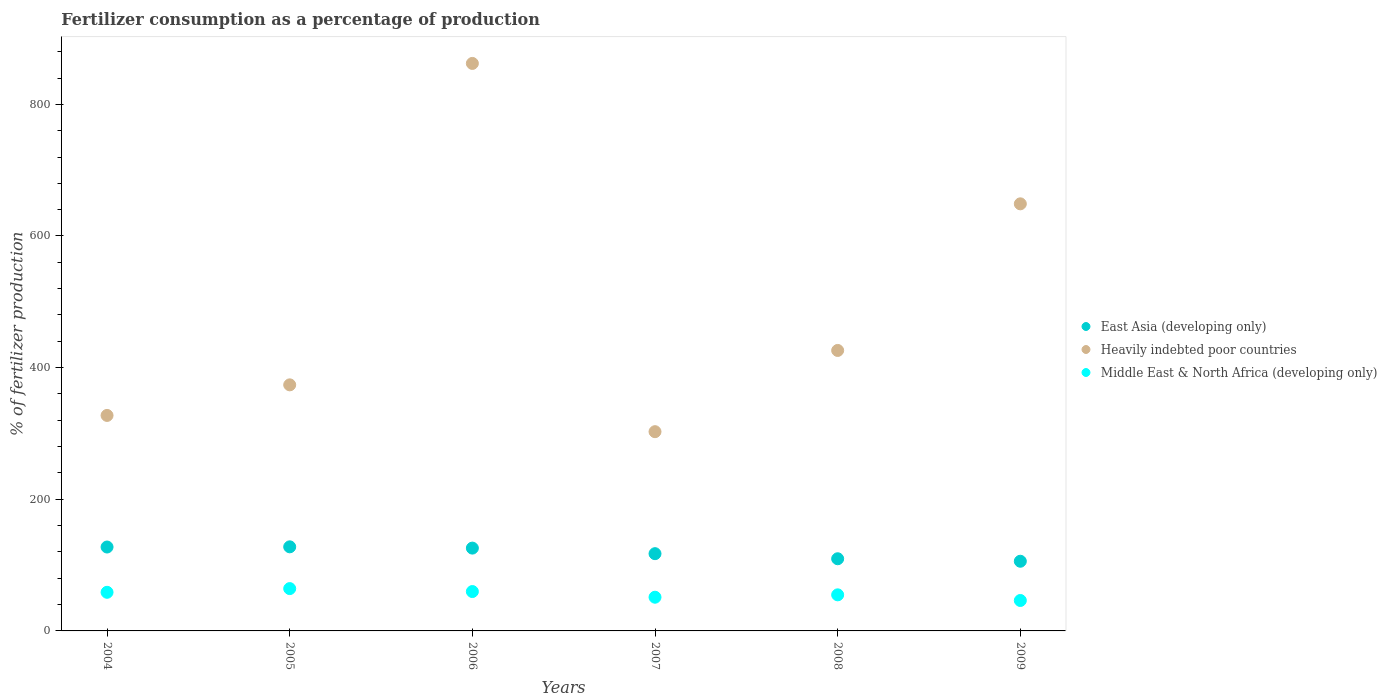What is the percentage of fertilizers consumed in East Asia (developing only) in 2006?
Your response must be concise. 125.81. Across all years, what is the maximum percentage of fertilizers consumed in East Asia (developing only)?
Keep it short and to the point. 127.76. Across all years, what is the minimum percentage of fertilizers consumed in East Asia (developing only)?
Keep it short and to the point. 105.86. In which year was the percentage of fertilizers consumed in Middle East & North Africa (developing only) minimum?
Provide a succinct answer. 2009. What is the total percentage of fertilizers consumed in Middle East & North Africa (developing only) in the graph?
Provide a short and direct response. 335.05. What is the difference between the percentage of fertilizers consumed in East Asia (developing only) in 2004 and that in 2009?
Provide a short and direct response. 21.61. What is the difference between the percentage of fertilizers consumed in Middle East & North Africa (developing only) in 2004 and the percentage of fertilizers consumed in Heavily indebted poor countries in 2008?
Make the answer very short. -367.43. What is the average percentage of fertilizers consumed in East Asia (developing only) per year?
Provide a succinct answer. 118.98. In the year 2005, what is the difference between the percentage of fertilizers consumed in East Asia (developing only) and percentage of fertilizers consumed in Heavily indebted poor countries?
Offer a terse response. -246.09. What is the ratio of the percentage of fertilizers consumed in Middle East & North Africa (developing only) in 2007 to that in 2009?
Ensure brevity in your answer.  1.11. Is the percentage of fertilizers consumed in Middle East & North Africa (developing only) in 2006 less than that in 2009?
Provide a succinct answer. No. Is the difference between the percentage of fertilizers consumed in East Asia (developing only) in 2008 and 2009 greater than the difference between the percentage of fertilizers consumed in Heavily indebted poor countries in 2008 and 2009?
Provide a short and direct response. Yes. What is the difference between the highest and the second highest percentage of fertilizers consumed in Heavily indebted poor countries?
Give a very brief answer. 213.31. What is the difference between the highest and the lowest percentage of fertilizers consumed in Middle East & North Africa (developing only)?
Provide a succinct answer. 18.06. Is the sum of the percentage of fertilizers consumed in East Asia (developing only) in 2007 and 2008 greater than the maximum percentage of fertilizers consumed in Heavily indebted poor countries across all years?
Make the answer very short. No. Does the percentage of fertilizers consumed in Middle East & North Africa (developing only) monotonically increase over the years?
Keep it short and to the point. No. Is the percentage of fertilizers consumed in Heavily indebted poor countries strictly greater than the percentage of fertilizers consumed in Middle East & North Africa (developing only) over the years?
Give a very brief answer. Yes. Is the percentage of fertilizers consumed in East Asia (developing only) strictly less than the percentage of fertilizers consumed in Heavily indebted poor countries over the years?
Your response must be concise. Yes. How many dotlines are there?
Offer a very short reply. 3. Where does the legend appear in the graph?
Give a very brief answer. Center right. How many legend labels are there?
Your answer should be very brief. 3. How are the legend labels stacked?
Make the answer very short. Vertical. What is the title of the graph?
Offer a terse response. Fertilizer consumption as a percentage of production. What is the label or title of the Y-axis?
Your answer should be very brief. % of fertilizer production. What is the % of fertilizer production in East Asia (developing only) in 2004?
Ensure brevity in your answer.  127.47. What is the % of fertilizer production of Heavily indebted poor countries in 2004?
Your answer should be very brief. 327.38. What is the % of fertilizer production in Middle East & North Africa (developing only) in 2004?
Offer a very short reply. 58.68. What is the % of fertilizer production in East Asia (developing only) in 2005?
Make the answer very short. 127.76. What is the % of fertilizer production of Heavily indebted poor countries in 2005?
Offer a terse response. 373.84. What is the % of fertilizer production in Middle East & North Africa (developing only) in 2005?
Give a very brief answer. 64.3. What is the % of fertilizer production in East Asia (developing only) in 2006?
Your response must be concise. 125.81. What is the % of fertilizer production in Heavily indebted poor countries in 2006?
Keep it short and to the point. 862.17. What is the % of fertilizer production in Middle East & North Africa (developing only) in 2006?
Provide a short and direct response. 59.82. What is the % of fertilizer production in East Asia (developing only) in 2007?
Offer a terse response. 117.36. What is the % of fertilizer production of Heavily indebted poor countries in 2007?
Make the answer very short. 302.7. What is the % of fertilizer production of Middle East & North Africa (developing only) in 2007?
Provide a short and direct response. 51.2. What is the % of fertilizer production in East Asia (developing only) in 2008?
Your answer should be compact. 109.65. What is the % of fertilizer production in Heavily indebted poor countries in 2008?
Give a very brief answer. 426.11. What is the % of fertilizer production in Middle East & North Africa (developing only) in 2008?
Offer a terse response. 54.82. What is the % of fertilizer production in East Asia (developing only) in 2009?
Offer a terse response. 105.86. What is the % of fertilizer production in Heavily indebted poor countries in 2009?
Keep it short and to the point. 648.85. What is the % of fertilizer production in Middle East & North Africa (developing only) in 2009?
Provide a succinct answer. 46.24. Across all years, what is the maximum % of fertilizer production in East Asia (developing only)?
Provide a short and direct response. 127.76. Across all years, what is the maximum % of fertilizer production in Heavily indebted poor countries?
Give a very brief answer. 862.17. Across all years, what is the maximum % of fertilizer production of Middle East & North Africa (developing only)?
Give a very brief answer. 64.3. Across all years, what is the minimum % of fertilizer production in East Asia (developing only)?
Offer a terse response. 105.86. Across all years, what is the minimum % of fertilizer production in Heavily indebted poor countries?
Keep it short and to the point. 302.7. Across all years, what is the minimum % of fertilizer production in Middle East & North Africa (developing only)?
Offer a very short reply. 46.24. What is the total % of fertilizer production in East Asia (developing only) in the graph?
Your response must be concise. 713.9. What is the total % of fertilizer production of Heavily indebted poor countries in the graph?
Offer a terse response. 2941.05. What is the total % of fertilizer production in Middle East & North Africa (developing only) in the graph?
Provide a succinct answer. 335.05. What is the difference between the % of fertilizer production of East Asia (developing only) in 2004 and that in 2005?
Your response must be concise. -0.29. What is the difference between the % of fertilizer production of Heavily indebted poor countries in 2004 and that in 2005?
Make the answer very short. -46.46. What is the difference between the % of fertilizer production of Middle East & North Africa (developing only) in 2004 and that in 2005?
Make the answer very short. -5.62. What is the difference between the % of fertilizer production in East Asia (developing only) in 2004 and that in 2006?
Keep it short and to the point. 1.65. What is the difference between the % of fertilizer production in Heavily indebted poor countries in 2004 and that in 2006?
Your answer should be very brief. -534.78. What is the difference between the % of fertilizer production in Middle East & North Africa (developing only) in 2004 and that in 2006?
Offer a terse response. -1.15. What is the difference between the % of fertilizer production in East Asia (developing only) in 2004 and that in 2007?
Offer a very short reply. 10.11. What is the difference between the % of fertilizer production of Heavily indebted poor countries in 2004 and that in 2007?
Provide a short and direct response. 24.69. What is the difference between the % of fertilizer production of Middle East & North Africa (developing only) in 2004 and that in 2007?
Your response must be concise. 7.47. What is the difference between the % of fertilizer production in East Asia (developing only) in 2004 and that in 2008?
Your answer should be compact. 17.82. What is the difference between the % of fertilizer production of Heavily indebted poor countries in 2004 and that in 2008?
Your answer should be compact. -98.72. What is the difference between the % of fertilizer production in Middle East & North Africa (developing only) in 2004 and that in 2008?
Your answer should be compact. 3.86. What is the difference between the % of fertilizer production in East Asia (developing only) in 2004 and that in 2009?
Provide a succinct answer. 21.61. What is the difference between the % of fertilizer production of Heavily indebted poor countries in 2004 and that in 2009?
Provide a short and direct response. -321.47. What is the difference between the % of fertilizer production of Middle East & North Africa (developing only) in 2004 and that in 2009?
Your response must be concise. 12.44. What is the difference between the % of fertilizer production of East Asia (developing only) in 2005 and that in 2006?
Give a very brief answer. 1.94. What is the difference between the % of fertilizer production in Heavily indebted poor countries in 2005 and that in 2006?
Make the answer very short. -488.32. What is the difference between the % of fertilizer production in Middle East & North Africa (developing only) in 2005 and that in 2006?
Your answer should be compact. 4.48. What is the difference between the % of fertilizer production of East Asia (developing only) in 2005 and that in 2007?
Your response must be concise. 10.39. What is the difference between the % of fertilizer production in Heavily indebted poor countries in 2005 and that in 2007?
Your response must be concise. 71.14. What is the difference between the % of fertilizer production in Middle East & North Africa (developing only) in 2005 and that in 2007?
Make the answer very short. 13.1. What is the difference between the % of fertilizer production of East Asia (developing only) in 2005 and that in 2008?
Give a very brief answer. 18.11. What is the difference between the % of fertilizer production in Heavily indebted poor countries in 2005 and that in 2008?
Make the answer very short. -52.27. What is the difference between the % of fertilizer production of Middle East & North Africa (developing only) in 2005 and that in 2008?
Provide a short and direct response. 9.48. What is the difference between the % of fertilizer production of East Asia (developing only) in 2005 and that in 2009?
Offer a terse response. 21.9. What is the difference between the % of fertilizer production in Heavily indebted poor countries in 2005 and that in 2009?
Ensure brevity in your answer.  -275.01. What is the difference between the % of fertilizer production of Middle East & North Africa (developing only) in 2005 and that in 2009?
Make the answer very short. 18.06. What is the difference between the % of fertilizer production in East Asia (developing only) in 2006 and that in 2007?
Offer a very short reply. 8.45. What is the difference between the % of fertilizer production of Heavily indebted poor countries in 2006 and that in 2007?
Offer a very short reply. 559.47. What is the difference between the % of fertilizer production in Middle East & North Africa (developing only) in 2006 and that in 2007?
Provide a short and direct response. 8.62. What is the difference between the % of fertilizer production in East Asia (developing only) in 2006 and that in 2008?
Provide a short and direct response. 16.17. What is the difference between the % of fertilizer production in Heavily indebted poor countries in 2006 and that in 2008?
Give a very brief answer. 436.06. What is the difference between the % of fertilizer production in Middle East & North Africa (developing only) in 2006 and that in 2008?
Ensure brevity in your answer.  5. What is the difference between the % of fertilizer production of East Asia (developing only) in 2006 and that in 2009?
Provide a short and direct response. 19.96. What is the difference between the % of fertilizer production in Heavily indebted poor countries in 2006 and that in 2009?
Offer a terse response. 213.31. What is the difference between the % of fertilizer production in Middle East & North Africa (developing only) in 2006 and that in 2009?
Provide a short and direct response. 13.58. What is the difference between the % of fertilizer production in East Asia (developing only) in 2007 and that in 2008?
Your response must be concise. 7.72. What is the difference between the % of fertilizer production in Heavily indebted poor countries in 2007 and that in 2008?
Your answer should be very brief. -123.41. What is the difference between the % of fertilizer production of Middle East & North Africa (developing only) in 2007 and that in 2008?
Offer a terse response. -3.61. What is the difference between the % of fertilizer production of East Asia (developing only) in 2007 and that in 2009?
Your answer should be very brief. 11.51. What is the difference between the % of fertilizer production in Heavily indebted poor countries in 2007 and that in 2009?
Offer a very short reply. -346.16. What is the difference between the % of fertilizer production of Middle East & North Africa (developing only) in 2007 and that in 2009?
Provide a succinct answer. 4.96. What is the difference between the % of fertilizer production of East Asia (developing only) in 2008 and that in 2009?
Your response must be concise. 3.79. What is the difference between the % of fertilizer production of Heavily indebted poor countries in 2008 and that in 2009?
Ensure brevity in your answer.  -222.75. What is the difference between the % of fertilizer production in Middle East & North Africa (developing only) in 2008 and that in 2009?
Provide a succinct answer. 8.58. What is the difference between the % of fertilizer production in East Asia (developing only) in 2004 and the % of fertilizer production in Heavily indebted poor countries in 2005?
Provide a succinct answer. -246.37. What is the difference between the % of fertilizer production of East Asia (developing only) in 2004 and the % of fertilizer production of Middle East & North Africa (developing only) in 2005?
Offer a very short reply. 63.17. What is the difference between the % of fertilizer production in Heavily indebted poor countries in 2004 and the % of fertilizer production in Middle East & North Africa (developing only) in 2005?
Provide a short and direct response. 263.09. What is the difference between the % of fertilizer production in East Asia (developing only) in 2004 and the % of fertilizer production in Heavily indebted poor countries in 2006?
Offer a very short reply. -734.7. What is the difference between the % of fertilizer production of East Asia (developing only) in 2004 and the % of fertilizer production of Middle East & North Africa (developing only) in 2006?
Give a very brief answer. 67.65. What is the difference between the % of fertilizer production in Heavily indebted poor countries in 2004 and the % of fertilizer production in Middle East & North Africa (developing only) in 2006?
Provide a succinct answer. 267.56. What is the difference between the % of fertilizer production in East Asia (developing only) in 2004 and the % of fertilizer production in Heavily indebted poor countries in 2007?
Offer a very short reply. -175.23. What is the difference between the % of fertilizer production of East Asia (developing only) in 2004 and the % of fertilizer production of Middle East & North Africa (developing only) in 2007?
Provide a succinct answer. 76.27. What is the difference between the % of fertilizer production in Heavily indebted poor countries in 2004 and the % of fertilizer production in Middle East & North Africa (developing only) in 2007?
Your answer should be very brief. 276.18. What is the difference between the % of fertilizer production of East Asia (developing only) in 2004 and the % of fertilizer production of Heavily indebted poor countries in 2008?
Your response must be concise. -298.64. What is the difference between the % of fertilizer production of East Asia (developing only) in 2004 and the % of fertilizer production of Middle East & North Africa (developing only) in 2008?
Keep it short and to the point. 72.65. What is the difference between the % of fertilizer production in Heavily indebted poor countries in 2004 and the % of fertilizer production in Middle East & North Africa (developing only) in 2008?
Your response must be concise. 272.57. What is the difference between the % of fertilizer production of East Asia (developing only) in 2004 and the % of fertilizer production of Heavily indebted poor countries in 2009?
Give a very brief answer. -521.39. What is the difference between the % of fertilizer production of East Asia (developing only) in 2004 and the % of fertilizer production of Middle East & North Africa (developing only) in 2009?
Your answer should be very brief. 81.23. What is the difference between the % of fertilizer production in Heavily indebted poor countries in 2004 and the % of fertilizer production in Middle East & North Africa (developing only) in 2009?
Ensure brevity in your answer.  281.14. What is the difference between the % of fertilizer production in East Asia (developing only) in 2005 and the % of fertilizer production in Heavily indebted poor countries in 2006?
Ensure brevity in your answer.  -734.41. What is the difference between the % of fertilizer production in East Asia (developing only) in 2005 and the % of fertilizer production in Middle East & North Africa (developing only) in 2006?
Offer a very short reply. 67.94. What is the difference between the % of fertilizer production of Heavily indebted poor countries in 2005 and the % of fertilizer production of Middle East & North Africa (developing only) in 2006?
Offer a terse response. 314.02. What is the difference between the % of fertilizer production in East Asia (developing only) in 2005 and the % of fertilizer production in Heavily indebted poor countries in 2007?
Your answer should be very brief. -174.94. What is the difference between the % of fertilizer production in East Asia (developing only) in 2005 and the % of fertilizer production in Middle East & North Africa (developing only) in 2007?
Make the answer very short. 76.56. What is the difference between the % of fertilizer production of Heavily indebted poor countries in 2005 and the % of fertilizer production of Middle East & North Africa (developing only) in 2007?
Keep it short and to the point. 322.64. What is the difference between the % of fertilizer production in East Asia (developing only) in 2005 and the % of fertilizer production in Heavily indebted poor countries in 2008?
Make the answer very short. -298.35. What is the difference between the % of fertilizer production of East Asia (developing only) in 2005 and the % of fertilizer production of Middle East & North Africa (developing only) in 2008?
Provide a short and direct response. 72.94. What is the difference between the % of fertilizer production in Heavily indebted poor countries in 2005 and the % of fertilizer production in Middle East & North Africa (developing only) in 2008?
Make the answer very short. 319.03. What is the difference between the % of fertilizer production in East Asia (developing only) in 2005 and the % of fertilizer production in Heavily indebted poor countries in 2009?
Keep it short and to the point. -521.1. What is the difference between the % of fertilizer production in East Asia (developing only) in 2005 and the % of fertilizer production in Middle East & North Africa (developing only) in 2009?
Your answer should be very brief. 81.52. What is the difference between the % of fertilizer production in Heavily indebted poor countries in 2005 and the % of fertilizer production in Middle East & North Africa (developing only) in 2009?
Your answer should be compact. 327.6. What is the difference between the % of fertilizer production of East Asia (developing only) in 2006 and the % of fertilizer production of Heavily indebted poor countries in 2007?
Offer a terse response. -176.88. What is the difference between the % of fertilizer production of East Asia (developing only) in 2006 and the % of fertilizer production of Middle East & North Africa (developing only) in 2007?
Ensure brevity in your answer.  74.61. What is the difference between the % of fertilizer production in Heavily indebted poor countries in 2006 and the % of fertilizer production in Middle East & North Africa (developing only) in 2007?
Provide a succinct answer. 810.96. What is the difference between the % of fertilizer production in East Asia (developing only) in 2006 and the % of fertilizer production in Heavily indebted poor countries in 2008?
Your response must be concise. -300.29. What is the difference between the % of fertilizer production in East Asia (developing only) in 2006 and the % of fertilizer production in Middle East & North Africa (developing only) in 2008?
Offer a very short reply. 71. What is the difference between the % of fertilizer production in Heavily indebted poor countries in 2006 and the % of fertilizer production in Middle East & North Africa (developing only) in 2008?
Keep it short and to the point. 807.35. What is the difference between the % of fertilizer production in East Asia (developing only) in 2006 and the % of fertilizer production in Heavily indebted poor countries in 2009?
Provide a succinct answer. -523.04. What is the difference between the % of fertilizer production of East Asia (developing only) in 2006 and the % of fertilizer production of Middle East & North Africa (developing only) in 2009?
Your answer should be compact. 79.58. What is the difference between the % of fertilizer production of Heavily indebted poor countries in 2006 and the % of fertilizer production of Middle East & North Africa (developing only) in 2009?
Your answer should be very brief. 815.93. What is the difference between the % of fertilizer production of East Asia (developing only) in 2007 and the % of fertilizer production of Heavily indebted poor countries in 2008?
Your answer should be very brief. -308.75. What is the difference between the % of fertilizer production of East Asia (developing only) in 2007 and the % of fertilizer production of Middle East & North Africa (developing only) in 2008?
Keep it short and to the point. 62.55. What is the difference between the % of fertilizer production of Heavily indebted poor countries in 2007 and the % of fertilizer production of Middle East & North Africa (developing only) in 2008?
Make the answer very short. 247.88. What is the difference between the % of fertilizer production in East Asia (developing only) in 2007 and the % of fertilizer production in Heavily indebted poor countries in 2009?
Ensure brevity in your answer.  -531.49. What is the difference between the % of fertilizer production of East Asia (developing only) in 2007 and the % of fertilizer production of Middle East & North Africa (developing only) in 2009?
Provide a short and direct response. 71.12. What is the difference between the % of fertilizer production of Heavily indebted poor countries in 2007 and the % of fertilizer production of Middle East & North Africa (developing only) in 2009?
Your answer should be very brief. 256.46. What is the difference between the % of fertilizer production in East Asia (developing only) in 2008 and the % of fertilizer production in Heavily indebted poor countries in 2009?
Offer a very short reply. -539.21. What is the difference between the % of fertilizer production in East Asia (developing only) in 2008 and the % of fertilizer production in Middle East & North Africa (developing only) in 2009?
Offer a terse response. 63.41. What is the difference between the % of fertilizer production in Heavily indebted poor countries in 2008 and the % of fertilizer production in Middle East & North Africa (developing only) in 2009?
Provide a short and direct response. 379.87. What is the average % of fertilizer production of East Asia (developing only) per year?
Your answer should be very brief. 118.98. What is the average % of fertilizer production of Heavily indebted poor countries per year?
Your answer should be compact. 490.18. What is the average % of fertilizer production of Middle East & North Africa (developing only) per year?
Make the answer very short. 55.84. In the year 2004, what is the difference between the % of fertilizer production in East Asia (developing only) and % of fertilizer production in Heavily indebted poor countries?
Provide a short and direct response. -199.92. In the year 2004, what is the difference between the % of fertilizer production in East Asia (developing only) and % of fertilizer production in Middle East & North Africa (developing only)?
Provide a short and direct response. 68.79. In the year 2004, what is the difference between the % of fertilizer production of Heavily indebted poor countries and % of fertilizer production of Middle East & North Africa (developing only)?
Provide a succinct answer. 268.71. In the year 2005, what is the difference between the % of fertilizer production in East Asia (developing only) and % of fertilizer production in Heavily indebted poor countries?
Keep it short and to the point. -246.09. In the year 2005, what is the difference between the % of fertilizer production in East Asia (developing only) and % of fertilizer production in Middle East & North Africa (developing only)?
Your answer should be very brief. 63.46. In the year 2005, what is the difference between the % of fertilizer production in Heavily indebted poor countries and % of fertilizer production in Middle East & North Africa (developing only)?
Your answer should be very brief. 309.54. In the year 2006, what is the difference between the % of fertilizer production in East Asia (developing only) and % of fertilizer production in Heavily indebted poor countries?
Offer a terse response. -736.35. In the year 2006, what is the difference between the % of fertilizer production in East Asia (developing only) and % of fertilizer production in Middle East & North Africa (developing only)?
Provide a short and direct response. 65.99. In the year 2006, what is the difference between the % of fertilizer production in Heavily indebted poor countries and % of fertilizer production in Middle East & North Africa (developing only)?
Keep it short and to the point. 802.35. In the year 2007, what is the difference between the % of fertilizer production of East Asia (developing only) and % of fertilizer production of Heavily indebted poor countries?
Provide a short and direct response. -185.33. In the year 2007, what is the difference between the % of fertilizer production of East Asia (developing only) and % of fertilizer production of Middle East & North Africa (developing only)?
Keep it short and to the point. 66.16. In the year 2007, what is the difference between the % of fertilizer production of Heavily indebted poor countries and % of fertilizer production of Middle East & North Africa (developing only)?
Provide a short and direct response. 251.5. In the year 2008, what is the difference between the % of fertilizer production in East Asia (developing only) and % of fertilizer production in Heavily indebted poor countries?
Give a very brief answer. -316.46. In the year 2008, what is the difference between the % of fertilizer production in East Asia (developing only) and % of fertilizer production in Middle East & North Africa (developing only)?
Your answer should be compact. 54.83. In the year 2008, what is the difference between the % of fertilizer production in Heavily indebted poor countries and % of fertilizer production in Middle East & North Africa (developing only)?
Offer a terse response. 371.29. In the year 2009, what is the difference between the % of fertilizer production of East Asia (developing only) and % of fertilizer production of Heavily indebted poor countries?
Give a very brief answer. -543. In the year 2009, what is the difference between the % of fertilizer production in East Asia (developing only) and % of fertilizer production in Middle East & North Africa (developing only)?
Offer a very short reply. 59.62. In the year 2009, what is the difference between the % of fertilizer production of Heavily indebted poor countries and % of fertilizer production of Middle East & North Africa (developing only)?
Give a very brief answer. 602.61. What is the ratio of the % of fertilizer production of East Asia (developing only) in 2004 to that in 2005?
Ensure brevity in your answer.  1. What is the ratio of the % of fertilizer production in Heavily indebted poor countries in 2004 to that in 2005?
Make the answer very short. 0.88. What is the ratio of the % of fertilizer production in Middle East & North Africa (developing only) in 2004 to that in 2005?
Provide a succinct answer. 0.91. What is the ratio of the % of fertilizer production of East Asia (developing only) in 2004 to that in 2006?
Provide a short and direct response. 1.01. What is the ratio of the % of fertilizer production in Heavily indebted poor countries in 2004 to that in 2006?
Provide a succinct answer. 0.38. What is the ratio of the % of fertilizer production of Middle East & North Africa (developing only) in 2004 to that in 2006?
Ensure brevity in your answer.  0.98. What is the ratio of the % of fertilizer production in East Asia (developing only) in 2004 to that in 2007?
Provide a short and direct response. 1.09. What is the ratio of the % of fertilizer production in Heavily indebted poor countries in 2004 to that in 2007?
Offer a terse response. 1.08. What is the ratio of the % of fertilizer production of Middle East & North Africa (developing only) in 2004 to that in 2007?
Your response must be concise. 1.15. What is the ratio of the % of fertilizer production in East Asia (developing only) in 2004 to that in 2008?
Your response must be concise. 1.16. What is the ratio of the % of fertilizer production in Heavily indebted poor countries in 2004 to that in 2008?
Offer a very short reply. 0.77. What is the ratio of the % of fertilizer production of Middle East & North Africa (developing only) in 2004 to that in 2008?
Give a very brief answer. 1.07. What is the ratio of the % of fertilizer production in East Asia (developing only) in 2004 to that in 2009?
Your answer should be very brief. 1.2. What is the ratio of the % of fertilizer production of Heavily indebted poor countries in 2004 to that in 2009?
Your response must be concise. 0.5. What is the ratio of the % of fertilizer production in Middle East & North Africa (developing only) in 2004 to that in 2009?
Provide a short and direct response. 1.27. What is the ratio of the % of fertilizer production in East Asia (developing only) in 2005 to that in 2006?
Your response must be concise. 1.02. What is the ratio of the % of fertilizer production of Heavily indebted poor countries in 2005 to that in 2006?
Offer a terse response. 0.43. What is the ratio of the % of fertilizer production of Middle East & North Africa (developing only) in 2005 to that in 2006?
Make the answer very short. 1.07. What is the ratio of the % of fertilizer production in East Asia (developing only) in 2005 to that in 2007?
Your response must be concise. 1.09. What is the ratio of the % of fertilizer production in Heavily indebted poor countries in 2005 to that in 2007?
Provide a succinct answer. 1.24. What is the ratio of the % of fertilizer production of Middle East & North Africa (developing only) in 2005 to that in 2007?
Your response must be concise. 1.26. What is the ratio of the % of fertilizer production in East Asia (developing only) in 2005 to that in 2008?
Offer a terse response. 1.17. What is the ratio of the % of fertilizer production in Heavily indebted poor countries in 2005 to that in 2008?
Offer a very short reply. 0.88. What is the ratio of the % of fertilizer production in Middle East & North Africa (developing only) in 2005 to that in 2008?
Give a very brief answer. 1.17. What is the ratio of the % of fertilizer production in East Asia (developing only) in 2005 to that in 2009?
Make the answer very short. 1.21. What is the ratio of the % of fertilizer production of Heavily indebted poor countries in 2005 to that in 2009?
Your answer should be very brief. 0.58. What is the ratio of the % of fertilizer production of Middle East & North Africa (developing only) in 2005 to that in 2009?
Ensure brevity in your answer.  1.39. What is the ratio of the % of fertilizer production of East Asia (developing only) in 2006 to that in 2007?
Offer a terse response. 1.07. What is the ratio of the % of fertilizer production of Heavily indebted poor countries in 2006 to that in 2007?
Your answer should be very brief. 2.85. What is the ratio of the % of fertilizer production of Middle East & North Africa (developing only) in 2006 to that in 2007?
Give a very brief answer. 1.17. What is the ratio of the % of fertilizer production of East Asia (developing only) in 2006 to that in 2008?
Keep it short and to the point. 1.15. What is the ratio of the % of fertilizer production in Heavily indebted poor countries in 2006 to that in 2008?
Your response must be concise. 2.02. What is the ratio of the % of fertilizer production of Middle East & North Africa (developing only) in 2006 to that in 2008?
Offer a very short reply. 1.09. What is the ratio of the % of fertilizer production of East Asia (developing only) in 2006 to that in 2009?
Keep it short and to the point. 1.19. What is the ratio of the % of fertilizer production of Heavily indebted poor countries in 2006 to that in 2009?
Give a very brief answer. 1.33. What is the ratio of the % of fertilizer production in Middle East & North Africa (developing only) in 2006 to that in 2009?
Provide a succinct answer. 1.29. What is the ratio of the % of fertilizer production in East Asia (developing only) in 2007 to that in 2008?
Give a very brief answer. 1.07. What is the ratio of the % of fertilizer production of Heavily indebted poor countries in 2007 to that in 2008?
Keep it short and to the point. 0.71. What is the ratio of the % of fertilizer production of Middle East & North Africa (developing only) in 2007 to that in 2008?
Ensure brevity in your answer.  0.93. What is the ratio of the % of fertilizer production of East Asia (developing only) in 2007 to that in 2009?
Make the answer very short. 1.11. What is the ratio of the % of fertilizer production in Heavily indebted poor countries in 2007 to that in 2009?
Your response must be concise. 0.47. What is the ratio of the % of fertilizer production in Middle East & North Africa (developing only) in 2007 to that in 2009?
Your answer should be compact. 1.11. What is the ratio of the % of fertilizer production of East Asia (developing only) in 2008 to that in 2009?
Your response must be concise. 1.04. What is the ratio of the % of fertilizer production of Heavily indebted poor countries in 2008 to that in 2009?
Your answer should be compact. 0.66. What is the ratio of the % of fertilizer production of Middle East & North Africa (developing only) in 2008 to that in 2009?
Ensure brevity in your answer.  1.19. What is the difference between the highest and the second highest % of fertilizer production of East Asia (developing only)?
Offer a very short reply. 0.29. What is the difference between the highest and the second highest % of fertilizer production in Heavily indebted poor countries?
Your answer should be very brief. 213.31. What is the difference between the highest and the second highest % of fertilizer production in Middle East & North Africa (developing only)?
Ensure brevity in your answer.  4.48. What is the difference between the highest and the lowest % of fertilizer production of East Asia (developing only)?
Ensure brevity in your answer.  21.9. What is the difference between the highest and the lowest % of fertilizer production of Heavily indebted poor countries?
Provide a short and direct response. 559.47. What is the difference between the highest and the lowest % of fertilizer production of Middle East & North Africa (developing only)?
Make the answer very short. 18.06. 